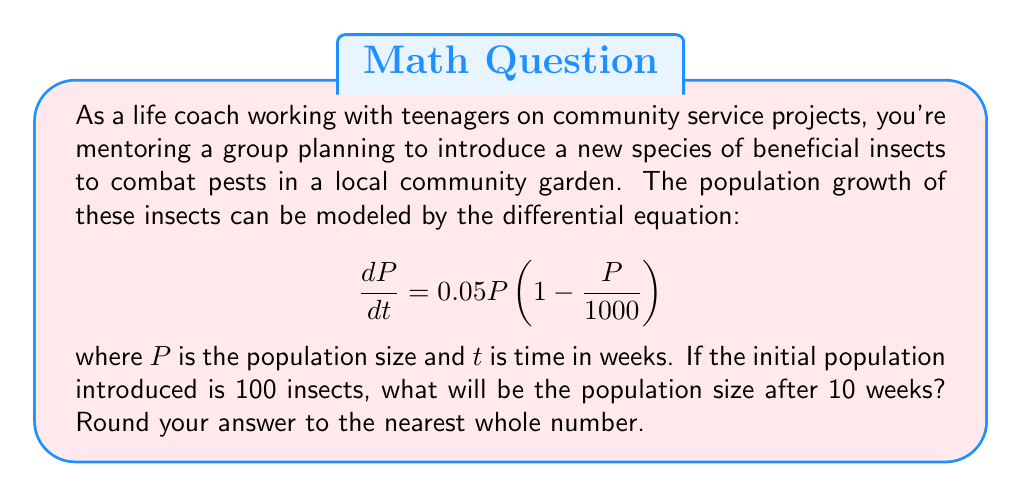Can you answer this question? Let's solve this step-by-step:

1) We have a logistic growth model with the following parameters:
   - Growth rate $r = 0.05$
   - Carrying capacity $K = 1000$
   - Initial population $P_0 = 100$
   - Time $t = 10$ weeks

2) The solution to the logistic growth equation is:

   $$P(t) = \frac{KP_0e^{rt}}{K + P_0(e^{rt} - 1)}$$

3) Let's substitute our values:

   $$P(10) = \frac{1000 \cdot 100 \cdot e^{0.05 \cdot 10}}{1000 + 100(e^{0.05 \cdot 10} - 1)}$$

4) Let's calculate $e^{0.05 \cdot 10}$:
   
   $$e^{0.5} \approx 1.6487$$

5) Now we can substitute this value:

   $$P(10) = \frac{1000 \cdot 100 \cdot 1.6487}{1000 + 100(1.6487 - 1)}$$

6) Simplify:

   $$P(10) = \frac{164,870}{1000 + 64.87} = \frac{164,870}{1064.87}$$

7) Calculate:

   $$P(10) \approx 154.83$$

8) Rounding to the nearest whole number:

   $$P(10) \approx 155$$
Answer: 155 insects 